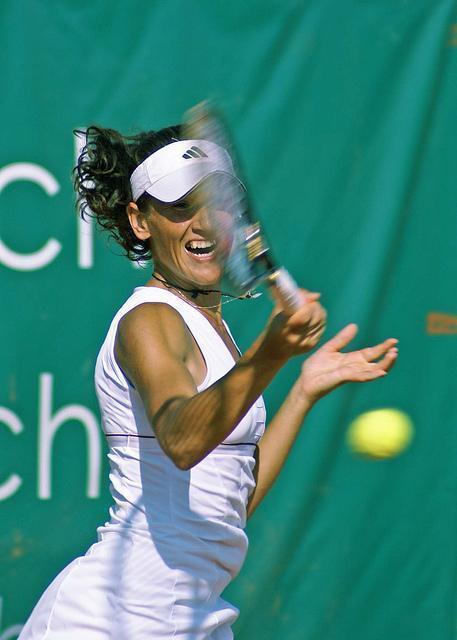Why is the racquet blurred?
Choose the correct response, then elucidate: 'Answer: answer
Rationale: rationale.'
Options: Rapid motion, falling apart, dropping it, out focus. Answer: rapid motion.
Rationale: When there is movement in a picture, it might come out blurry. the woman is swinging the racket in the picture. 